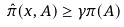<formula> <loc_0><loc_0><loc_500><loc_500>\hat { \pi } ( x , A ) & \geq \gamma \pi ( A ) \\</formula> 